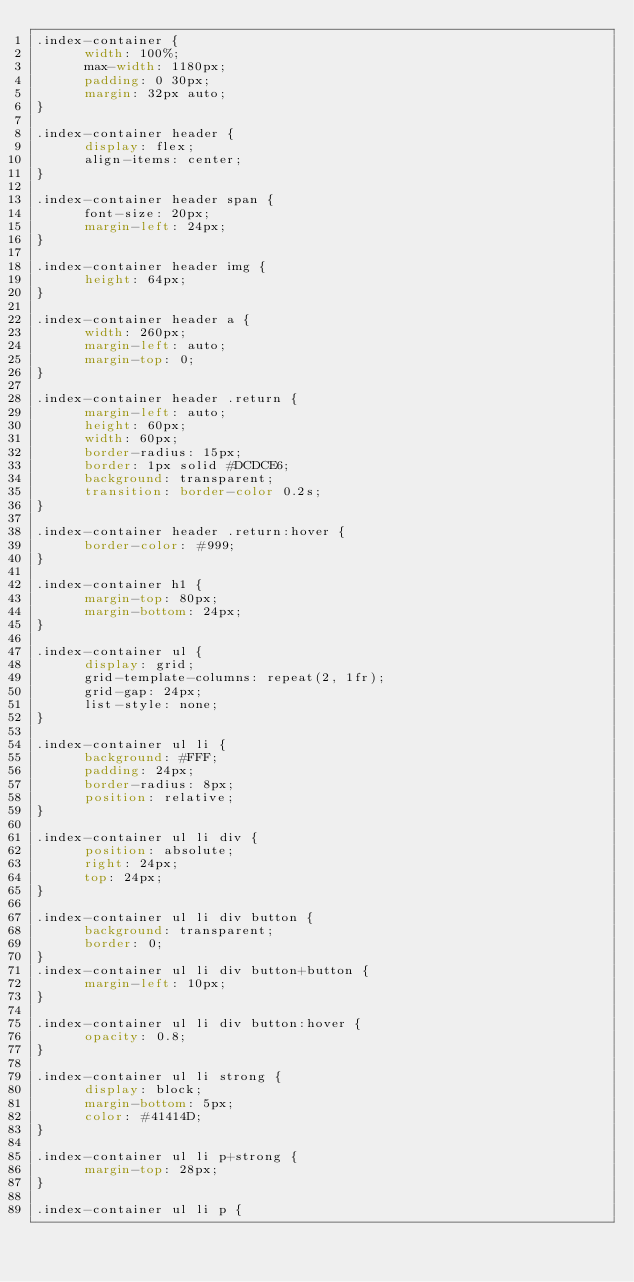<code> <loc_0><loc_0><loc_500><loc_500><_CSS_>.index-container {
      width: 100%;
      max-width: 1180px;
      padding: 0 30px;
      margin: 32px auto;
}

.index-container header {
      display: flex;
      align-items: center;
}

.index-container header span {
      font-size: 20px;
      margin-left: 24px;
}

.index-container header img {
      height: 64px;
}

.index-container header a {
      width: 260px;
      margin-left: auto;
      margin-top: 0;
}

.index-container header .return {
      margin-left: auto;
      height: 60px;
      width: 60px;
      border-radius: 15px;
      border: 1px solid #DCDCE6;
      background: transparent;
      transition: border-color 0.2s;
}

.index-container header .return:hover {
      border-color: #999;
}

.index-container h1 {
      margin-top: 80px;
      margin-bottom: 24px;
}

.index-container ul {
      display: grid;
      grid-template-columns: repeat(2, 1fr);
      grid-gap: 24px;
      list-style: none;
}

.index-container ul li {
      background: #FFF;
      padding: 24px;
      border-radius: 8px;
      position: relative;
}

.index-container ul li div {
      position: absolute;
      right: 24px;
      top: 24px;
}

.index-container ul li div button {
      background: transparent;
      border: 0;
}
.index-container ul li div button+button {
      margin-left: 10px;
}

.index-container ul li div button:hover {
      opacity: 0.8;
}

.index-container ul li strong {
      display: block;
      margin-bottom: 5px;
      color: #41414D;
}

.index-container ul li p+strong {
      margin-top: 28px;
}

.index-container ul li p {</code> 